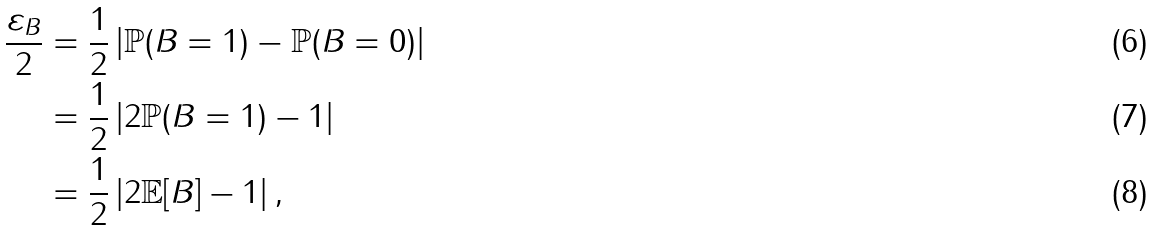Convert formula to latex. <formula><loc_0><loc_0><loc_500><loc_500>\frac { \varepsilon _ { B } } { 2 } & = \frac { 1 } { 2 } \left | \mathbb { P } ( B = 1 ) - \mathbb { P } ( B = 0 ) \right | \\ & = \frac { 1 } { 2 } \left | 2 \mathbb { P } ( B = 1 ) - 1 \right | \\ & = \frac { 1 } { 2 } \left | 2 \mathbb { E } [ B ] - 1 \right | ,</formula> 